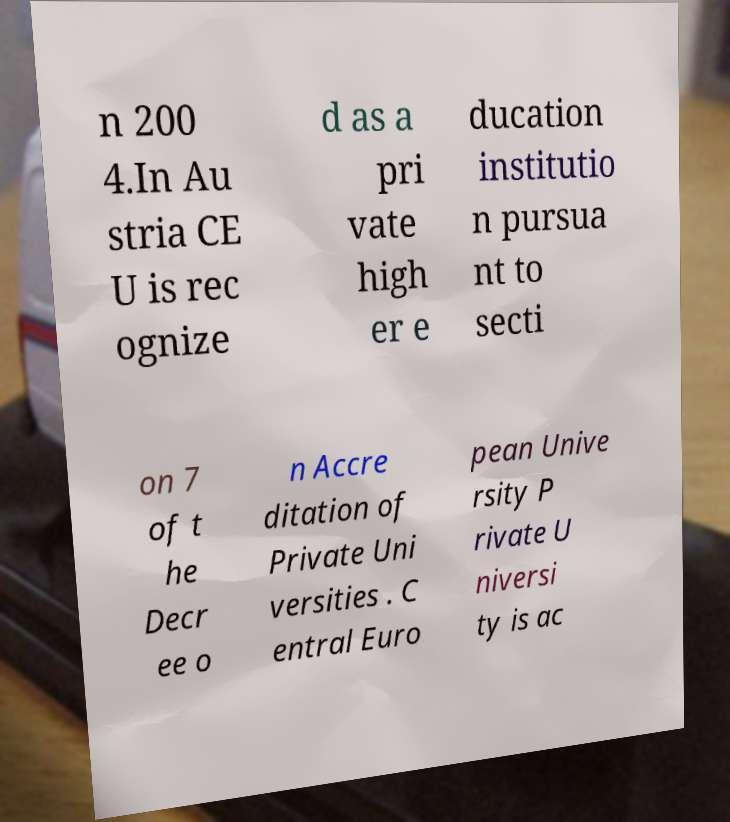I need the written content from this picture converted into text. Can you do that? n 200 4.In Au stria CE U is rec ognize d as a pri vate high er e ducation institutio n pursua nt to secti on 7 of t he Decr ee o n Accre ditation of Private Uni versities . C entral Euro pean Unive rsity P rivate U niversi ty is ac 